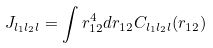<formula> <loc_0><loc_0><loc_500><loc_500>J _ { l _ { 1 } l _ { 2 } l } = \int r _ { 1 2 } ^ { 4 } d r _ { 1 2 } C _ { l _ { 1 } l _ { 2 } l } ( r _ { 1 2 } )</formula> 